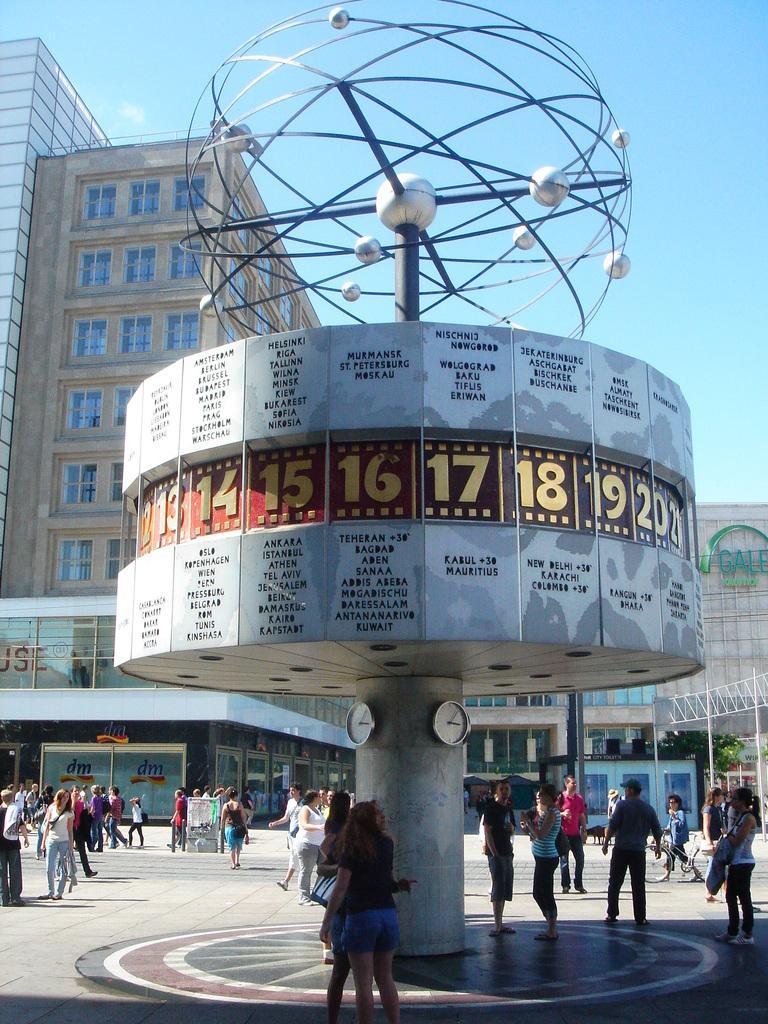Can you describe this image briefly? In this image, we can see an architecture with clocks. At the bottom of the image, we can see people are on the path. Background we can see tree, rods, buildings, walls, glass windows and sky. 